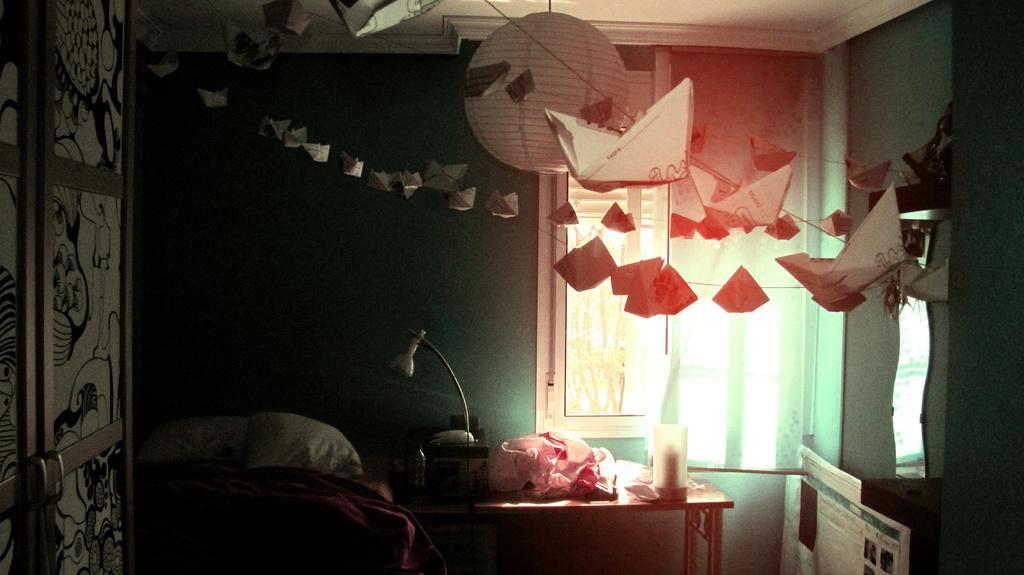Can you describe this image briefly? This image is taken indoors. In the background there is a wall. There is a window and there is a curtain. At the top of the image there is a roof. There is a paper lamp. There are many toy ships tied with a rope. On the left side of the image there is a wardrobe. In the middle of the image there is a table with a few things on it. There is a bed. On the right side of the image there is a mirror. 